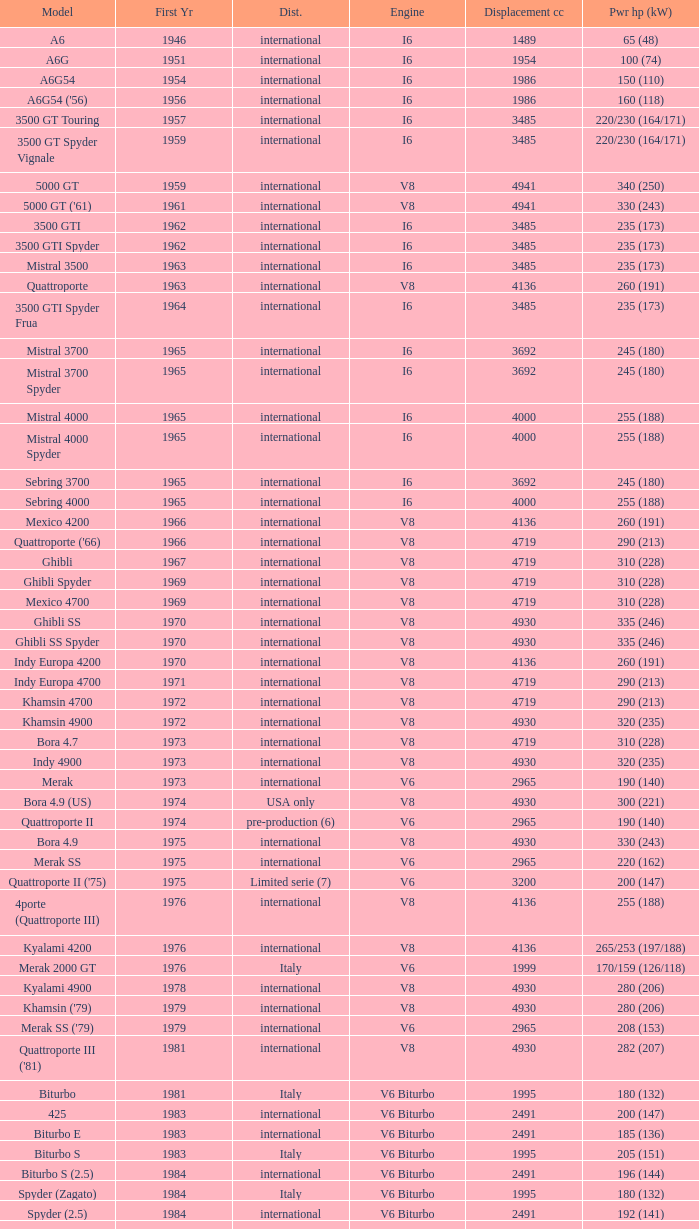What is the total number of First Year, when Displacement CC is greater than 4719, when Engine is V8, when Power HP (kW) is "335 (246)", and when Model is "Ghibli SS"? 1.0. 